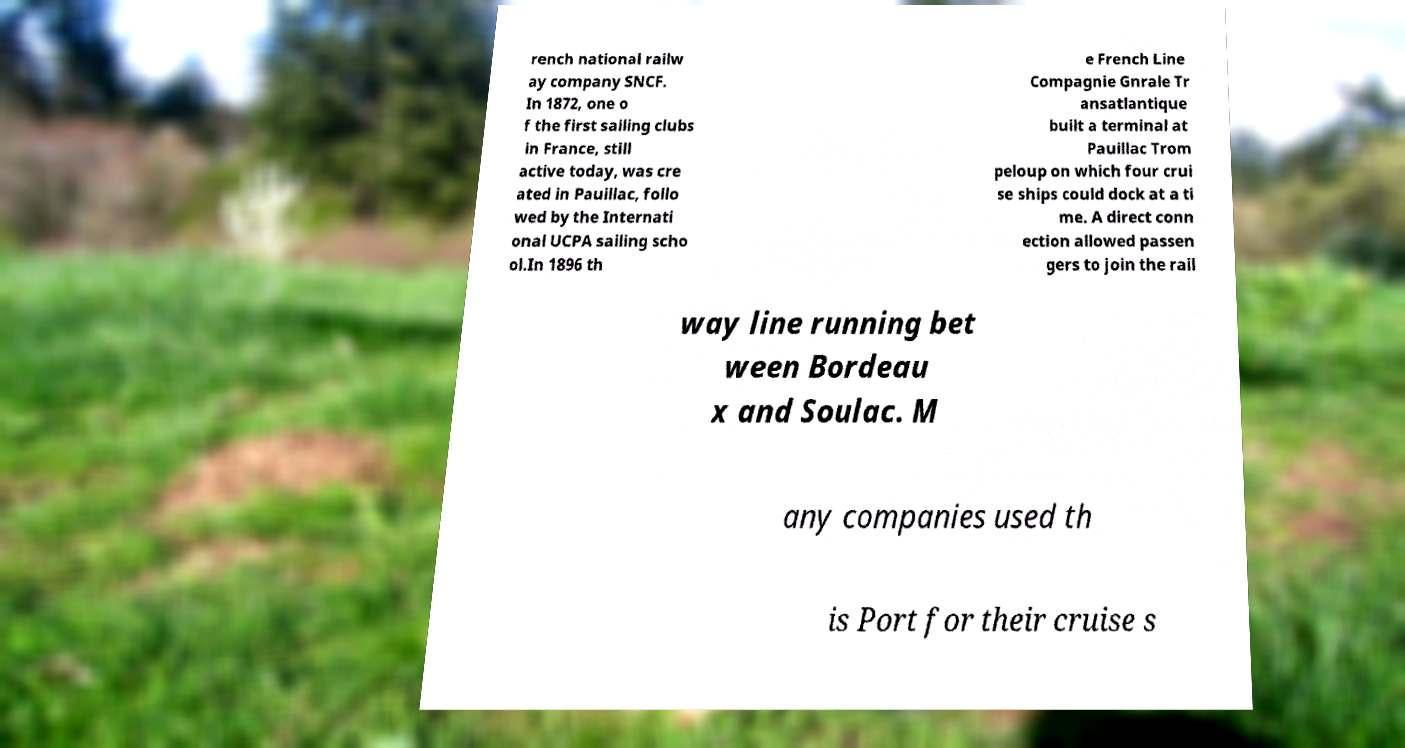What messages or text are displayed in this image? I need them in a readable, typed format. rench national railw ay company SNCF. In 1872, one o f the first sailing clubs in France, still active today, was cre ated in Pauillac, follo wed by the Internati onal UCPA sailing scho ol.In 1896 th e French Line Compagnie Gnrale Tr ansatlantique built a terminal at Pauillac Trom peloup on which four crui se ships could dock at a ti me. A direct conn ection allowed passen gers to join the rail way line running bet ween Bordeau x and Soulac. M any companies used th is Port for their cruise s 